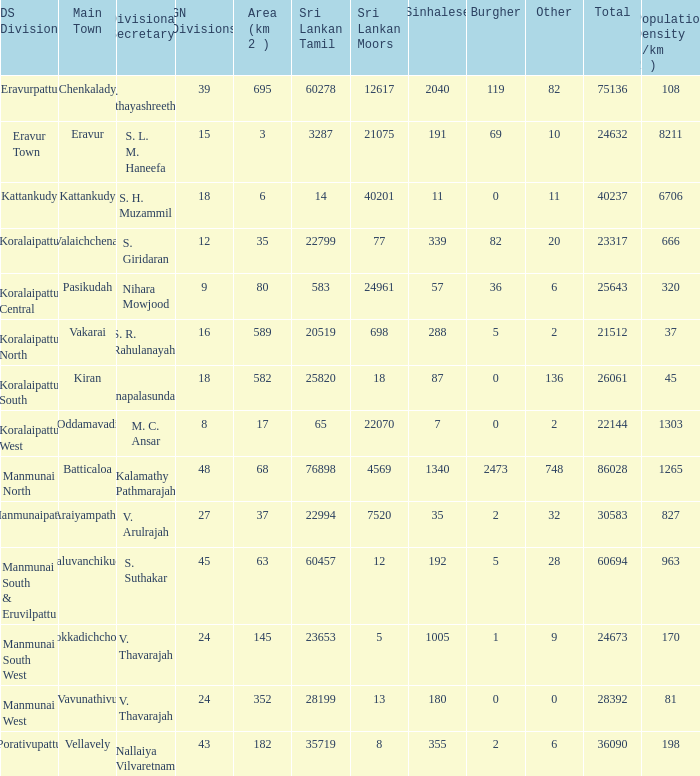Kaluvanchikudy is the main town in what DS division? Manmunai South & Eruvilpattu. 